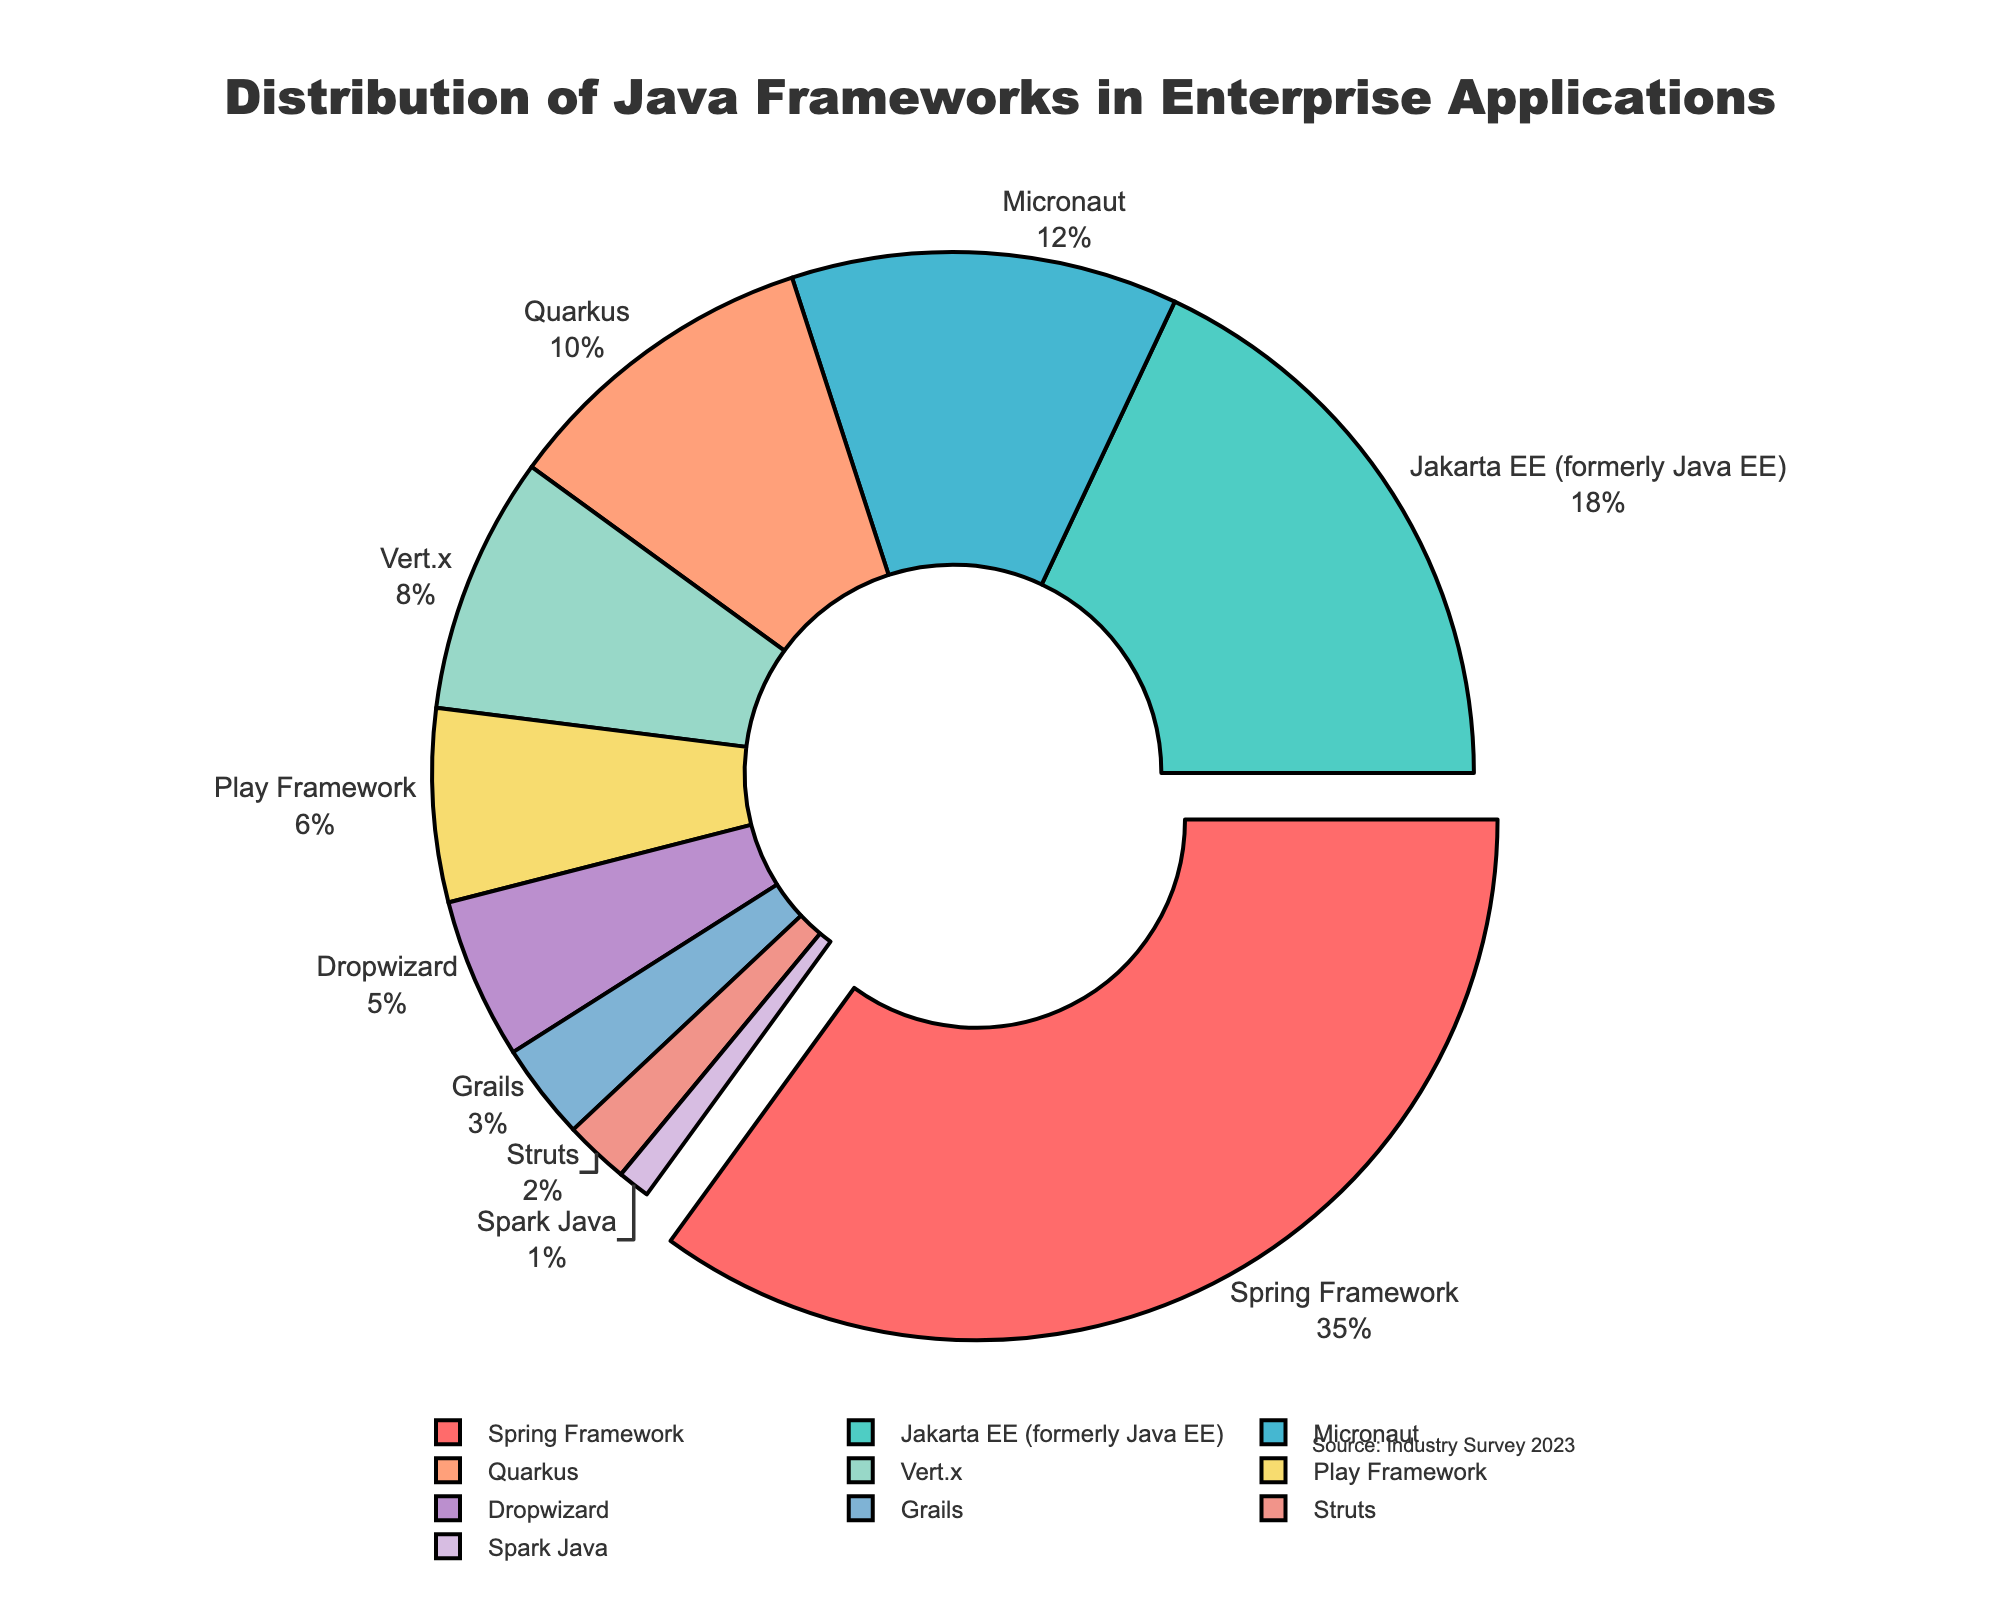Which Java framework is used the most in enterprise applications? The Spring Framework has the largest percentage in the chart with 35%.
Answer: Spring Framework Which two frameworks together account for more than 50% of the distribution? The Spring Framework (35%) and Jakarta EE (18%) add up to 53%, which is more than 50%.
Answer: Spring Framework and Jakarta EE How much more popular is the Spring Framework compared to Micronaut? The Spring Framework has 35%, and Micronaut has 12%. The difference is 35% - 12% = 23%.
Answer: 23% Which framework is represented by the smallest segment in the pie chart? The smallest segment belongs to Spark Java which has 1% of the distribution.
Answer: Spark Java What percentage of frameworks have less than 10% distribution each? Frameworks with less than 10% each are Quarkus (10%), Vert.x (8%), Play Framework (6%), Dropwizard (5%), Grails (3%), Struts (2%), and Spark Java (1%). Summing them up, 10% + 8% + 6% + 5% + 3% + 2% + 1% = 35%.
Answer: 35% Compare the combined percentage of Quarkus and Vert.x to the percentage of Spring Framework. Which is higher and by how much? Quarkus has 10% and Vert.x has 8%, combined 10% + 8% = 18%. The Spring Framework has 35%. The Spring Framework is higher by 35% - 18% = 17%.
Answer: Spring Framework is higher by 17% What is the combined total for frameworks with a percentage of 5% and above? Frameworks 5% and above are Spring Framework (35%), Jakarta EE (18%), Micronaut (12%), Quarkus (10%), Vert.x (8%), and Play Framework (6%). Summing these gives 35% + 18% + 12% + 10% + 8% + 6% = 89%.
Answer: 89% Which colored segment indicates the framework with the highest usage, and what is the color? The segment with the highest usage is for the Spring Framework, and it is red-colored.
Answer: Red 